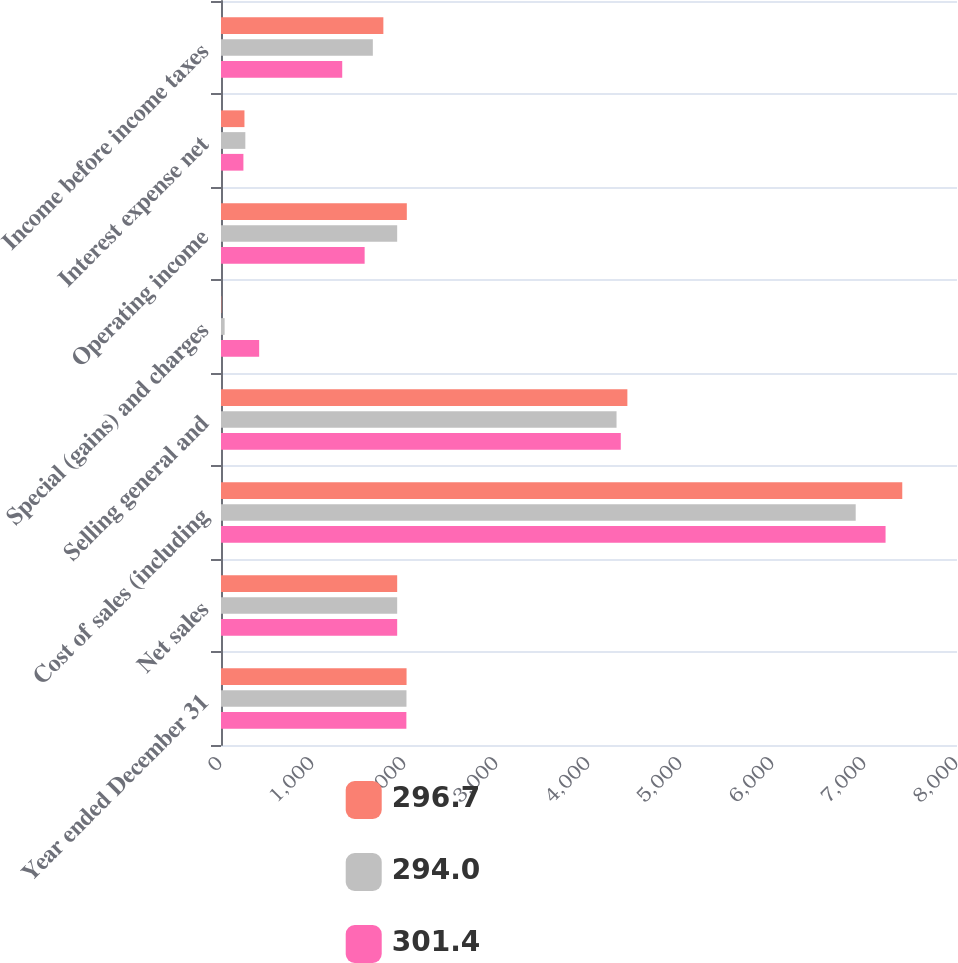Convert chart. <chart><loc_0><loc_0><loc_500><loc_500><stacked_bar_chart><ecel><fcel>Year ended December 31<fcel>Net sales<fcel>Cost of sales (including<fcel>Selling general and<fcel>Special (gains) and charges<fcel>Operating income<fcel>Interest expense net<fcel>Income before income taxes<nl><fcel>296.7<fcel>2017<fcel>1915<fcel>7405.1<fcel>4417.1<fcel>3.7<fcel>2019.8<fcel>255<fcel>1764.8<nl><fcel>294<fcel>2016<fcel>1915<fcel>6898.9<fcel>4299.4<fcel>39.5<fcel>1915<fcel>264.6<fcel>1650.4<nl><fcel>301.4<fcel>2015<fcel>1915<fcel>7223.5<fcel>4345.5<fcel>414.8<fcel>1561.3<fcel>243.6<fcel>1317.7<nl></chart> 